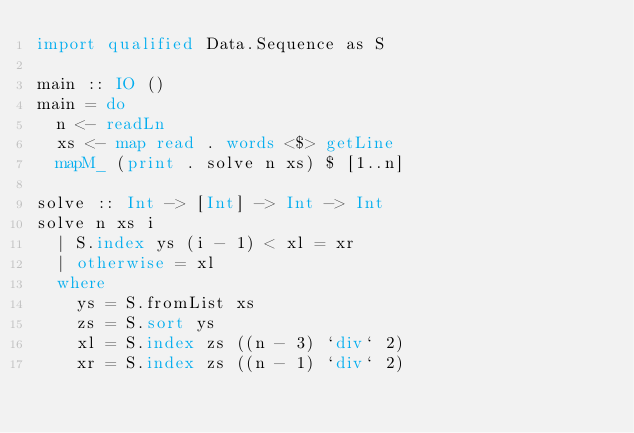Convert code to text. <code><loc_0><loc_0><loc_500><loc_500><_Haskell_>import qualified Data.Sequence as S

main :: IO ()
main = do
  n <- readLn
  xs <- map read . words <$> getLine
  mapM_ (print . solve n xs) $ [1..n]

solve :: Int -> [Int] -> Int -> Int
solve n xs i
  | S.index ys (i - 1) < xl = xr
  | otherwise = xl
  where
    ys = S.fromList xs
    zs = S.sort ys
    xl = S.index zs ((n - 3) `div` 2)
    xr = S.index zs ((n - 1) `div` 2)


</code> 